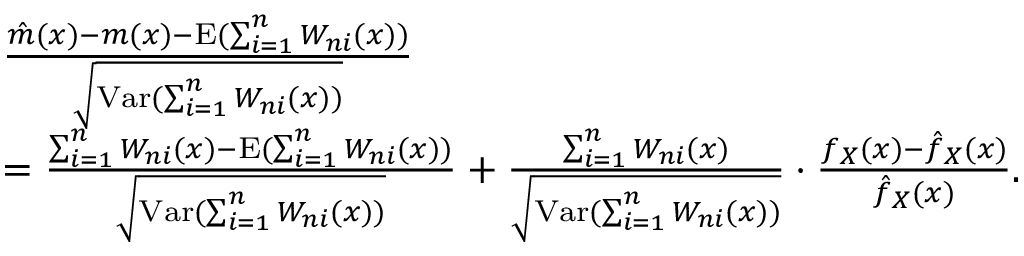<formula> <loc_0><loc_0><loc_500><loc_500>\begin{array} { r l } & { \frac { \hat { m } ( x ) - m ( x ) - E ( \sum _ { i = 1 } ^ { n } W _ { n i } ( x ) ) } { \sqrt { V a r ( \sum _ { i = 1 } ^ { n } W _ { n i } ( x ) ) } } } \\ & { = \frac { \sum _ { i = 1 } ^ { n } W _ { n i } ( x ) - E ( \sum _ { i = 1 } ^ { n } W _ { n i } ( x ) ) } { \sqrt { V a r ( \sum _ { i = 1 } ^ { n } W _ { n i } ( x ) ) } } + \frac { \sum _ { i = 1 } ^ { n } W _ { n i } ( x ) } { \sqrt { V a r ( \sum _ { i = 1 } ^ { n } W _ { n i } ( x ) ) } } \cdot \frac { f _ { X } ( x ) - \hat { f } _ { X } ( x ) } { \hat { f } _ { X } ( x ) } . } \end{array}</formula> 